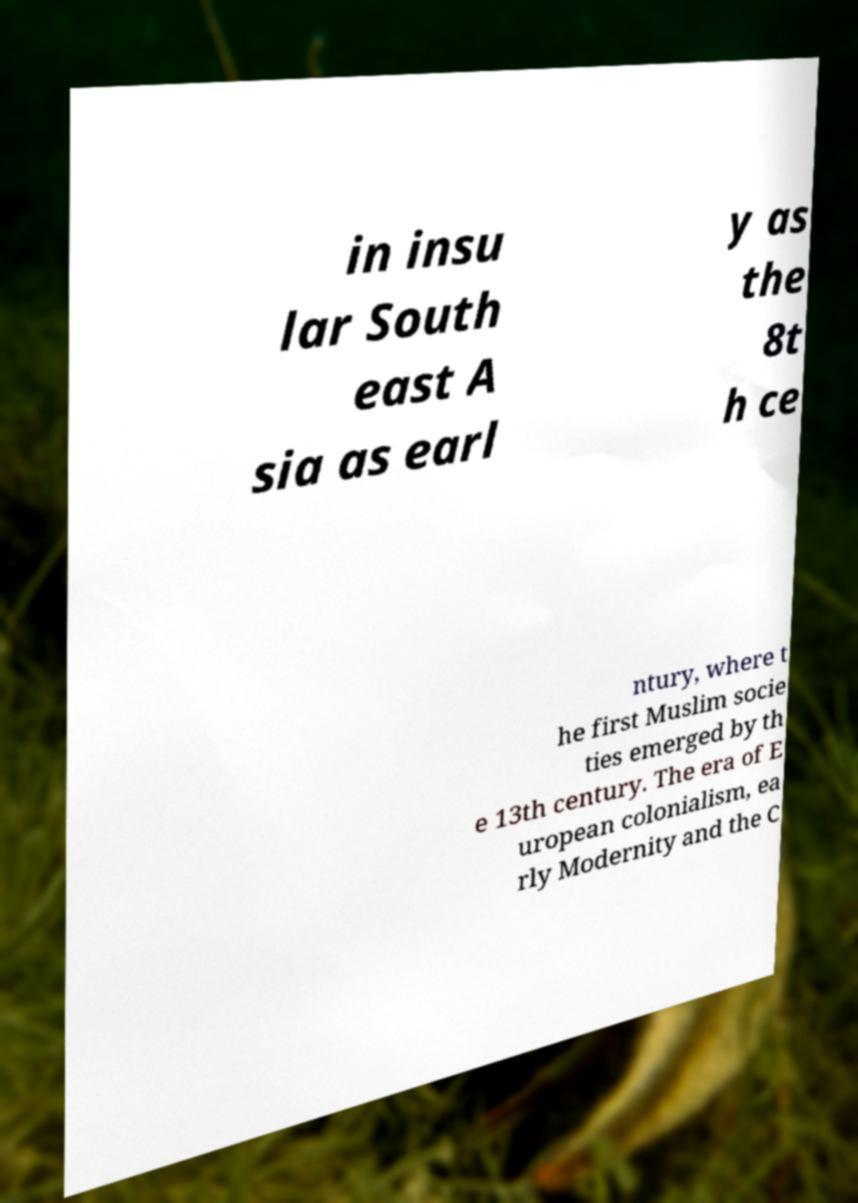I need the written content from this picture converted into text. Can you do that? in insu lar South east A sia as earl y as the 8t h ce ntury, where t he first Muslim socie ties emerged by th e 13th century. The era of E uropean colonialism, ea rly Modernity and the C 